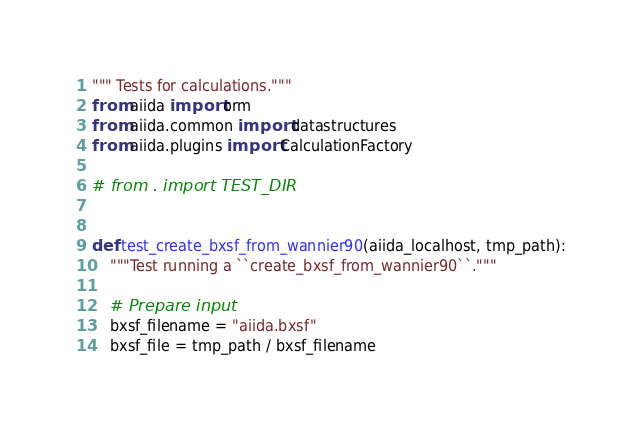<code> <loc_0><loc_0><loc_500><loc_500><_Python_>""" Tests for calculations."""
from aiida import orm
from aiida.common import datastructures
from aiida.plugins import CalculationFactory

# from . import TEST_DIR


def test_create_bxsf_from_wannier90(aiida_localhost, tmp_path):
    """Test running a ``create_bxsf_from_wannier90``."""

    # Prepare input
    bxsf_filename = "aiida.bxsf"
    bxsf_file = tmp_path / bxsf_filename</code> 